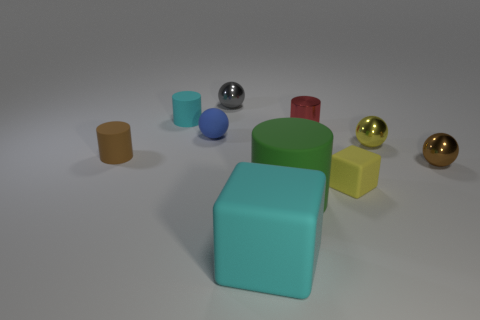Subtract all small metallic spheres. How many spheres are left? 1 Subtract all blue balls. How many balls are left? 3 Subtract all cylinders. How many objects are left? 6 Subtract 4 balls. How many balls are left? 0 Subtract all blue cylinders. Subtract all red blocks. How many cylinders are left? 4 Subtract all green cylinders. How many cyan blocks are left? 1 Subtract all gray rubber cylinders. Subtract all yellow shiny things. How many objects are left? 9 Add 9 metal cylinders. How many metal cylinders are left? 10 Add 5 tiny purple matte cylinders. How many tiny purple matte cylinders exist? 5 Subtract 1 yellow spheres. How many objects are left? 9 